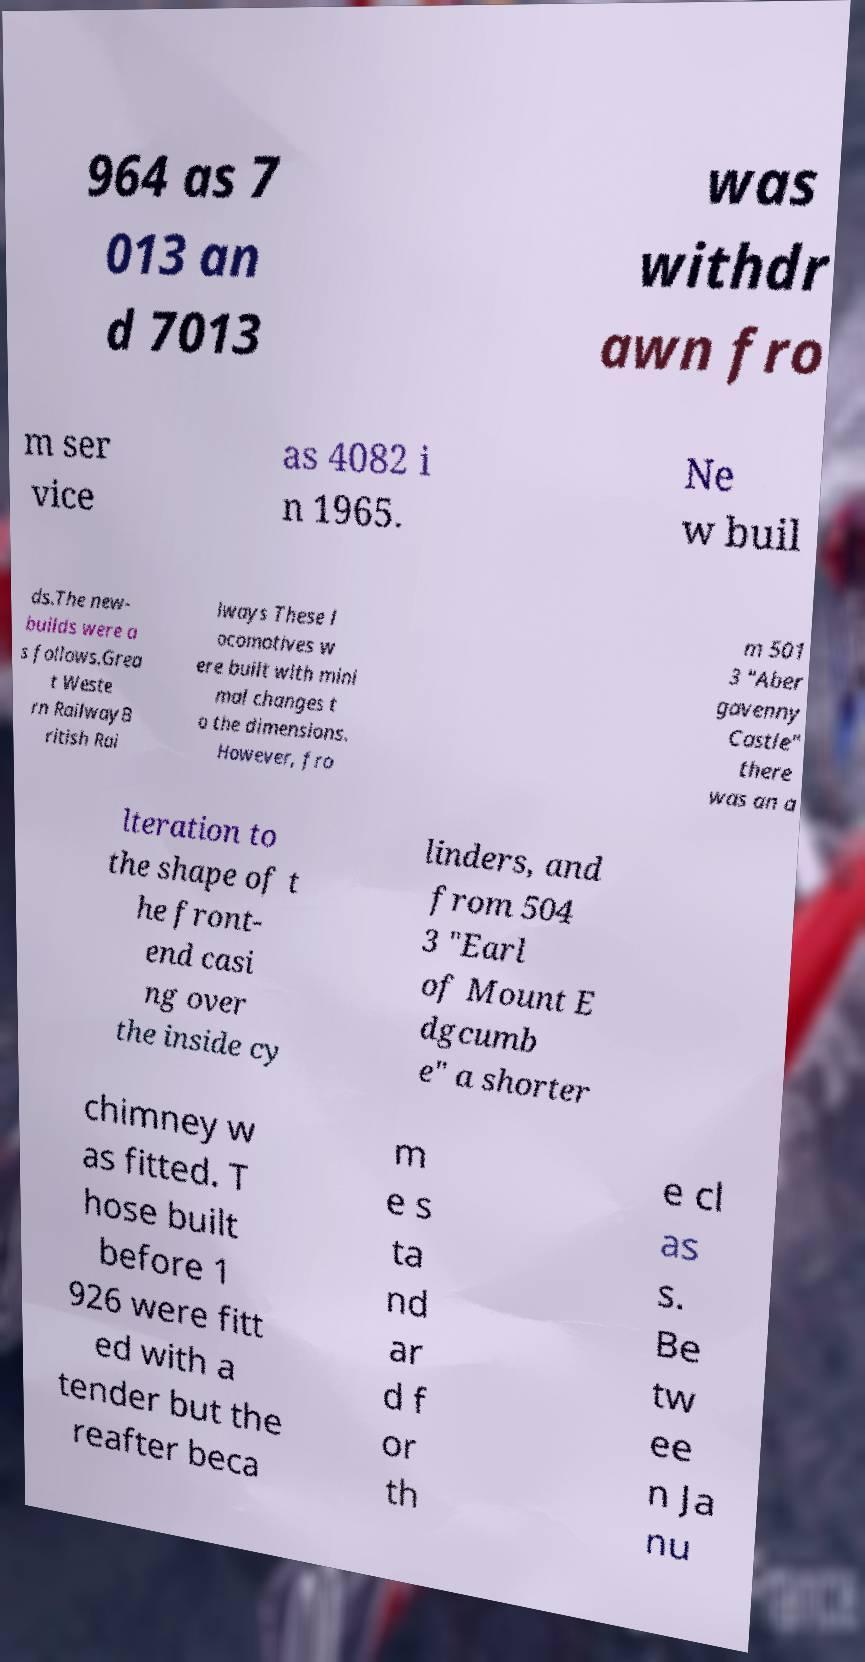Could you extract and type out the text from this image? 964 as 7 013 an d 7013 was withdr awn fro m ser vice as 4082 i n 1965. Ne w buil ds.The new- builds were a s follows.Grea t Weste rn RailwayB ritish Rai lways These l ocomotives w ere built with mini mal changes t o the dimensions. However, fro m 501 3 "Aber gavenny Castle" there was an a lteration to the shape of t he front- end casi ng over the inside cy linders, and from 504 3 "Earl of Mount E dgcumb e" a shorter chimney w as fitted. T hose built before 1 926 were fitt ed with a tender but the reafter beca m e s ta nd ar d f or th e cl as s. Be tw ee n Ja nu 